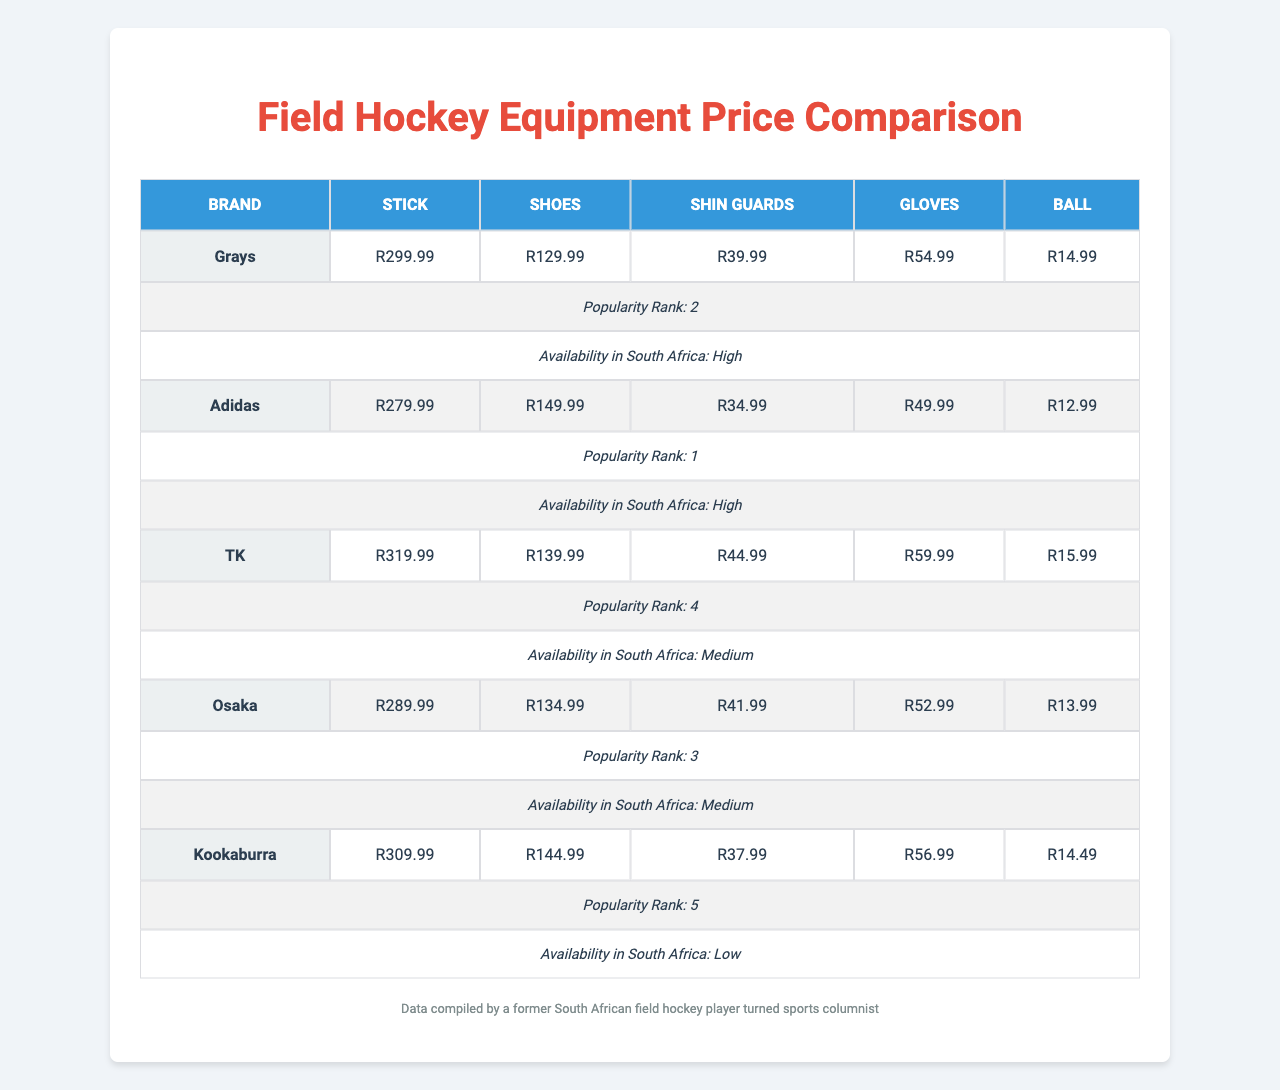What is the price of a stick from TK? The price of a stick from TK can be found in the table under the TK row and Stick column. It shows R319.99.
Answer: R319.99 Which brand has the cheapest shoes? To determine the cheapest shoes, I look at the prices of shoes across all brands. Adidas at R149.99 has the highest price, so the lowest is Grays at R129.99.
Answer: Grays What is the average price of shin guards across all brands? The shin guard prices are R39.99 (Grays), R34.99 (Adidas), R44.99 (TK), R41.99 (Osaka), and R37.99 (Kookaburra). Calculating the average: (39.99 + 34.99 + 44.99 + 41.99 + 37.99) / 5 = 39.99.
Answer: R39.99 Is the availability of Kookaburra equipment high in South Africa? The table indicates that the availability of Kookaburra equipment in South Africa is low.
Answer: No Which brand offers gloves at the highest price? I check the gloves prices across all brands: R54.99 (Grays), R49.99 (Adidas), R59.99 (TK), R52.99 (Osaka), and R56.99 (Kookaburra). TK has the highest price at R59.99.
Answer: TK What is the total cost of purchasing one of each item from Osaka? To find this, I sum the individual prices for Osaka: Stick R289.99 + Shoes R134.99 + Shin Guards R41.99 + Gloves R52.99 + Ball R13.99 = R633.95.
Answer: R633.95 Does Grays rank as more popular than Kookaburra? The popularity ranks can be checked: Grays is ranked 2 while Kookaburra is ranked 5. Therefore, Grays is indeed more popular.
Answer: Yes Which equipment has the highest price from any brand, and what is the price? I review all the equipment prices from different brands. The highest price for a stick is from TK at R319.99.
Answer: Stick from TK, R319.99 How much cheaper is the ball from Adidas compared to Kookaburra? The ball prices are R12.99 (Adidas) and R14.49 (Kookaburra). The difference is R14.49 - R12.99 = R1.50.
Answer: R1.50 What is the total number of brands that have high availability in South Africa? Reviewing the availability, Grays and Adidas both have high availability, which totals to 2 brands.
Answer: 2 